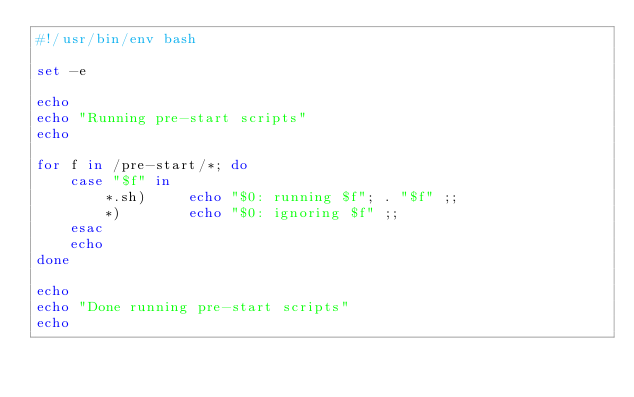<code> <loc_0><loc_0><loc_500><loc_500><_Bash_>#!/usr/bin/env bash

set -e

echo
echo "Running pre-start scripts"
echo

for f in /pre-start/*; do
    case "$f" in
        *.sh)     echo "$0: running $f"; . "$f" ;;
        *)        echo "$0: ignoring $f" ;;
    esac
    echo
done

echo
echo "Done running pre-start scripts"
echo
</code> 